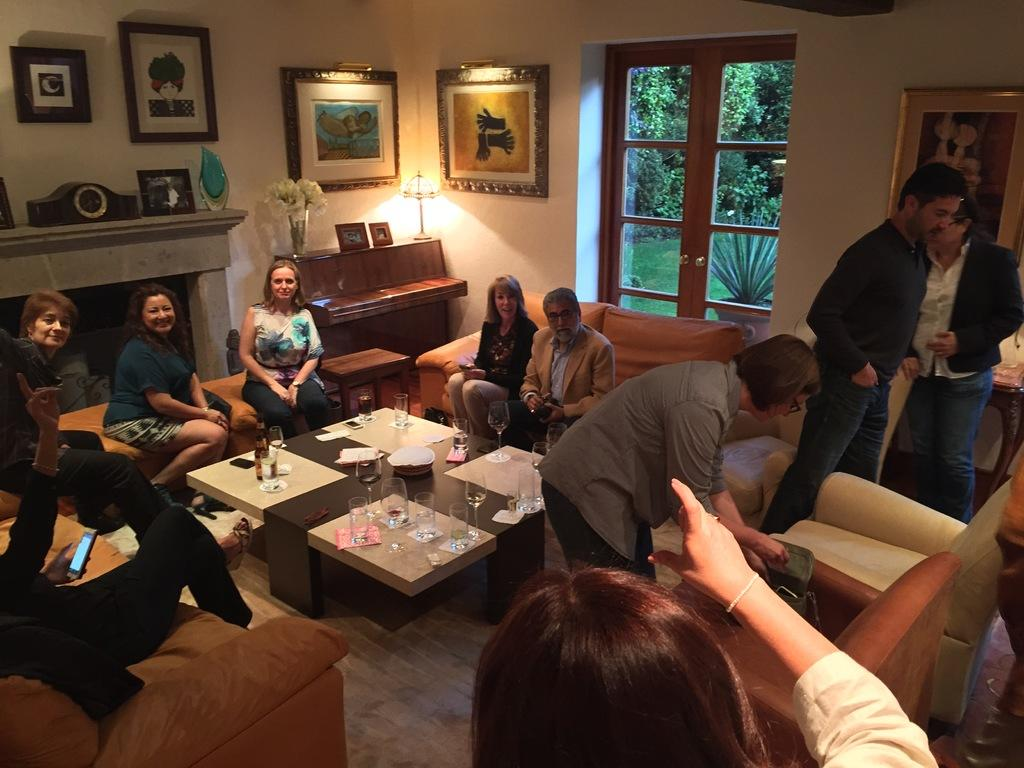What type of structure can be seen in the image? There is a wall in the image. What feature allows light and air into the room? There is a window in the image. What can be seen outside the window? Trees are visible in the image. What type of decorative items are present in the image? There are photo frames in the image. What type of furniture can be seen in the image? There are people sitting on sofas in the image. What is on the table in the image? There are glasses, bottles, and tissues on the table. What type of canvas is being used for the division in the image? There is no canvas or division present in the image. How do the people sitting on the sofas wash their hands in the image? There is no indication of handwashing in the image. 